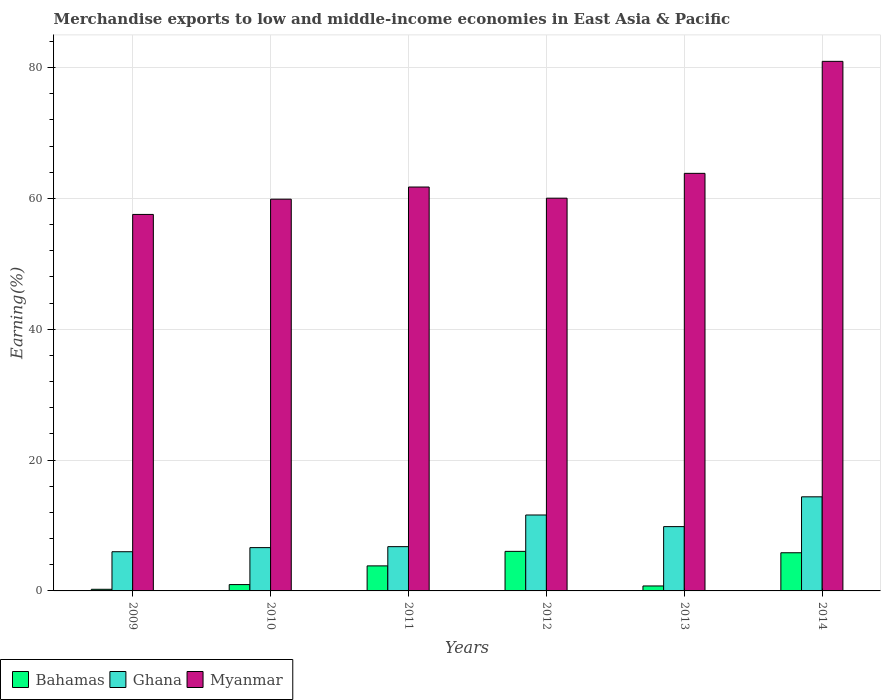How many different coloured bars are there?
Your response must be concise. 3. How many groups of bars are there?
Your answer should be compact. 6. Are the number of bars per tick equal to the number of legend labels?
Keep it short and to the point. Yes. How many bars are there on the 2nd tick from the left?
Provide a succinct answer. 3. What is the label of the 5th group of bars from the left?
Keep it short and to the point. 2013. What is the percentage of amount earned from merchandise exports in Bahamas in 2014?
Ensure brevity in your answer.  5.83. Across all years, what is the maximum percentage of amount earned from merchandise exports in Bahamas?
Provide a succinct answer. 6.05. Across all years, what is the minimum percentage of amount earned from merchandise exports in Ghana?
Make the answer very short. 5.99. What is the total percentage of amount earned from merchandise exports in Bahamas in the graph?
Make the answer very short. 17.68. What is the difference between the percentage of amount earned from merchandise exports in Bahamas in 2011 and that in 2014?
Offer a very short reply. -2.01. What is the difference between the percentage of amount earned from merchandise exports in Myanmar in 2009 and the percentage of amount earned from merchandise exports in Ghana in 2012?
Offer a terse response. 45.94. What is the average percentage of amount earned from merchandise exports in Bahamas per year?
Keep it short and to the point. 2.95. In the year 2012, what is the difference between the percentage of amount earned from merchandise exports in Myanmar and percentage of amount earned from merchandise exports in Ghana?
Your answer should be compact. 48.43. In how many years, is the percentage of amount earned from merchandise exports in Myanmar greater than 76 %?
Your response must be concise. 1. What is the ratio of the percentage of amount earned from merchandise exports in Bahamas in 2009 to that in 2014?
Your answer should be compact. 0.04. Is the percentage of amount earned from merchandise exports in Myanmar in 2011 less than that in 2014?
Your response must be concise. Yes. What is the difference between the highest and the second highest percentage of amount earned from merchandise exports in Myanmar?
Ensure brevity in your answer.  17.12. What is the difference between the highest and the lowest percentage of amount earned from merchandise exports in Bahamas?
Provide a short and direct response. 5.8. In how many years, is the percentage of amount earned from merchandise exports in Myanmar greater than the average percentage of amount earned from merchandise exports in Myanmar taken over all years?
Your answer should be compact. 1. Is the sum of the percentage of amount earned from merchandise exports in Ghana in 2009 and 2012 greater than the maximum percentage of amount earned from merchandise exports in Myanmar across all years?
Your answer should be very brief. No. What does the 1st bar from the left in 2010 represents?
Your answer should be very brief. Bahamas. What does the 3rd bar from the right in 2013 represents?
Your response must be concise. Bahamas. Is it the case that in every year, the sum of the percentage of amount earned from merchandise exports in Ghana and percentage of amount earned from merchandise exports in Bahamas is greater than the percentage of amount earned from merchandise exports in Myanmar?
Keep it short and to the point. No. How many bars are there?
Give a very brief answer. 18. How many years are there in the graph?
Your answer should be very brief. 6. Are the values on the major ticks of Y-axis written in scientific E-notation?
Make the answer very short. No. How many legend labels are there?
Offer a terse response. 3. How are the legend labels stacked?
Offer a very short reply. Horizontal. What is the title of the graph?
Ensure brevity in your answer.  Merchandise exports to low and middle-income economies in East Asia & Pacific. Does "Euro area" appear as one of the legend labels in the graph?
Your answer should be very brief. No. What is the label or title of the X-axis?
Offer a terse response. Years. What is the label or title of the Y-axis?
Your response must be concise. Earning(%). What is the Earning(%) of Bahamas in 2009?
Your answer should be compact. 0.25. What is the Earning(%) of Ghana in 2009?
Your response must be concise. 5.99. What is the Earning(%) of Myanmar in 2009?
Ensure brevity in your answer.  57.55. What is the Earning(%) of Bahamas in 2010?
Ensure brevity in your answer.  0.97. What is the Earning(%) in Ghana in 2010?
Provide a short and direct response. 6.62. What is the Earning(%) in Myanmar in 2010?
Your response must be concise. 59.88. What is the Earning(%) in Bahamas in 2011?
Your answer should be compact. 3.83. What is the Earning(%) in Ghana in 2011?
Offer a very short reply. 6.77. What is the Earning(%) in Myanmar in 2011?
Offer a very short reply. 61.73. What is the Earning(%) in Bahamas in 2012?
Keep it short and to the point. 6.05. What is the Earning(%) of Ghana in 2012?
Your response must be concise. 11.6. What is the Earning(%) of Myanmar in 2012?
Provide a short and direct response. 60.03. What is the Earning(%) in Bahamas in 2013?
Provide a short and direct response. 0.76. What is the Earning(%) in Ghana in 2013?
Offer a very short reply. 9.83. What is the Earning(%) of Myanmar in 2013?
Your answer should be very brief. 63.82. What is the Earning(%) in Bahamas in 2014?
Give a very brief answer. 5.83. What is the Earning(%) in Ghana in 2014?
Your answer should be compact. 14.38. What is the Earning(%) of Myanmar in 2014?
Provide a succinct answer. 80.94. Across all years, what is the maximum Earning(%) in Bahamas?
Ensure brevity in your answer.  6.05. Across all years, what is the maximum Earning(%) of Ghana?
Provide a succinct answer. 14.38. Across all years, what is the maximum Earning(%) of Myanmar?
Offer a very short reply. 80.94. Across all years, what is the minimum Earning(%) of Bahamas?
Your answer should be compact. 0.25. Across all years, what is the minimum Earning(%) of Ghana?
Your response must be concise. 5.99. Across all years, what is the minimum Earning(%) in Myanmar?
Keep it short and to the point. 57.55. What is the total Earning(%) in Bahamas in the graph?
Your response must be concise. 17.68. What is the total Earning(%) of Ghana in the graph?
Offer a very short reply. 55.2. What is the total Earning(%) in Myanmar in the graph?
Ensure brevity in your answer.  383.95. What is the difference between the Earning(%) of Bahamas in 2009 and that in 2010?
Your response must be concise. -0.72. What is the difference between the Earning(%) in Ghana in 2009 and that in 2010?
Provide a short and direct response. -0.63. What is the difference between the Earning(%) of Myanmar in 2009 and that in 2010?
Your response must be concise. -2.33. What is the difference between the Earning(%) of Bahamas in 2009 and that in 2011?
Give a very brief answer. -3.58. What is the difference between the Earning(%) in Ghana in 2009 and that in 2011?
Your answer should be very brief. -0.78. What is the difference between the Earning(%) in Myanmar in 2009 and that in 2011?
Offer a very short reply. -4.19. What is the difference between the Earning(%) in Bahamas in 2009 and that in 2012?
Your answer should be very brief. -5.8. What is the difference between the Earning(%) in Ghana in 2009 and that in 2012?
Offer a terse response. -5.61. What is the difference between the Earning(%) of Myanmar in 2009 and that in 2012?
Offer a terse response. -2.48. What is the difference between the Earning(%) in Bahamas in 2009 and that in 2013?
Keep it short and to the point. -0.51. What is the difference between the Earning(%) in Ghana in 2009 and that in 2013?
Give a very brief answer. -3.84. What is the difference between the Earning(%) in Myanmar in 2009 and that in 2013?
Provide a succinct answer. -6.28. What is the difference between the Earning(%) of Bahamas in 2009 and that in 2014?
Provide a short and direct response. -5.58. What is the difference between the Earning(%) of Ghana in 2009 and that in 2014?
Your answer should be very brief. -8.39. What is the difference between the Earning(%) in Myanmar in 2009 and that in 2014?
Your response must be concise. -23.4. What is the difference between the Earning(%) in Bahamas in 2010 and that in 2011?
Give a very brief answer. -2.86. What is the difference between the Earning(%) in Ghana in 2010 and that in 2011?
Provide a succinct answer. -0.15. What is the difference between the Earning(%) of Myanmar in 2010 and that in 2011?
Your answer should be very brief. -1.86. What is the difference between the Earning(%) of Bahamas in 2010 and that in 2012?
Provide a short and direct response. -5.08. What is the difference between the Earning(%) of Ghana in 2010 and that in 2012?
Make the answer very short. -4.98. What is the difference between the Earning(%) of Myanmar in 2010 and that in 2012?
Provide a succinct answer. -0.15. What is the difference between the Earning(%) of Bahamas in 2010 and that in 2013?
Your answer should be compact. 0.21. What is the difference between the Earning(%) of Ghana in 2010 and that in 2013?
Provide a succinct answer. -3.21. What is the difference between the Earning(%) in Myanmar in 2010 and that in 2013?
Provide a succinct answer. -3.95. What is the difference between the Earning(%) of Bahamas in 2010 and that in 2014?
Your response must be concise. -4.87. What is the difference between the Earning(%) of Ghana in 2010 and that in 2014?
Provide a short and direct response. -7.76. What is the difference between the Earning(%) of Myanmar in 2010 and that in 2014?
Your answer should be very brief. -21.07. What is the difference between the Earning(%) in Bahamas in 2011 and that in 2012?
Keep it short and to the point. -2.22. What is the difference between the Earning(%) in Ghana in 2011 and that in 2012?
Keep it short and to the point. -4.84. What is the difference between the Earning(%) in Myanmar in 2011 and that in 2012?
Your answer should be compact. 1.7. What is the difference between the Earning(%) in Bahamas in 2011 and that in 2013?
Your answer should be compact. 3.07. What is the difference between the Earning(%) in Ghana in 2011 and that in 2013?
Your response must be concise. -3.06. What is the difference between the Earning(%) of Myanmar in 2011 and that in 2013?
Ensure brevity in your answer.  -2.09. What is the difference between the Earning(%) of Bahamas in 2011 and that in 2014?
Provide a succinct answer. -2.01. What is the difference between the Earning(%) in Ghana in 2011 and that in 2014?
Keep it short and to the point. -7.61. What is the difference between the Earning(%) in Myanmar in 2011 and that in 2014?
Provide a short and direct response. -19.21. What is the difference between the Earning(%) of Bahamas in 2012 and that in 2013?
Your answer should be very brief. 5.29. What is the difference between the Earning(%) in Ghana in 2012 and that in 2013?
Your answer should be compact. 1.78. What is the difference between the Earning(%) of Myanmar in 2012 and that in 2013?
Your answer should be compact. -3.79. What is the difference between the Earning(%) in Bahamas in 2012 and that in 2014?
Your response must be concise. 0.21. What is the difference between the Earning(%) in Ghana in 2012 and that in 2014?
Ensure brevity in your answer.  -2.78. What is the difference between the Earning(%) of Myanmar in 2012 and that in 2014?
Offer a terse response. -20.91. What is the difference between the Earning(%) of Bahamas in 2013 and that in 2014?
Provide a succinct answer. -5.08. What is the difference between the Earning(%) of Ghana in 2013 and that in 2014?
Offer a terse response. -4.55. What is the difference between the Earning(%) in Myanmar in 2013 and that in 2014?
Make the answer very short. -17.12. What is the difference between the Earning(%) in Bahamas in 2009 and the Earning(%) in Ghana in 2010?
Your answer should be very brief. -6.37. What is the difference between the Earning(%) of Bahamas in 2009 and the Earning(%) of Myanmar in 2010?
Provide a short and direct response. -59.63. What is the difference between the Earning(%) in Ghana in 2009 and the Earning(%) in Myanmar in 2010?
Give a very brief answer. -53.89. What is the difference between the Earning(%) in Bahamas in 2009 and the Earning(%) in Ghana in 2011?
Ensure brevity in your answer.  -6.52. What is the difference between the Earning(%) in Bahamas in 2009 and the Earning(%) in Myanmar in 2011?
Give a very brief answer. -61.49. What is the difference between the Earning(%) of Ghana in 2009 and the Earning(%) of Myanmar in 2011?
Ensure brevity in your answer.  -55.74. What is the difference between the Earning(%) in Bahamas in 2009 and the Earning(%) in Ghana in 2012?
Give a very brief answer. -11.36. What is the difference between the Earning(%) in Bahamas in 2009 and the Earning(%) in Myanmar in 2012?
Provide a short and direct response. -59.78. What is the difference between the Earning(%) of Ghana in 2009 and the Earning(%) of Myanmar in 2012?
Keep it short and to the point. -54.04. What is the difference between the Earning(%) of Bahamas in 2009 and the Earning(%) of Ghana in 2013?
Your answer should be compact. -9.58. What is the difference between the Earning(%) of Bahamas in 2009 and the Earning(%) of Myanmar in 2013?
Provide a succinct answer. -63.57. What is the difference between the Earning(%) in Ghana in 2009 and the Earning(%) in Myanmar in 2013?
Offer a very short reply. -57.83. What is the difference between the Earning(%) of Bahamas in 2009 and the Earning(%) of Ghana in 2014?
Provide a succinct answer. -14.13. What is the difference between the Earning(%) in Bahamas in 2009 and the Earning(%) in Myanmar in 2014?
Provide a short and direct response. -80.69. What is the difference between the Earning(%) in Ghana in 2009 and the Earning(%) in Myanmar in 2014?
Give a very brief answer. -74.95. What is the difference between the Earning(%) in Bahamas in 2010 and the Earning(%) in Ghana in 2011?
Offer a very short reply. -5.8. What is the difference between the Earning(%) in Bahamas in 2010 and the Earning(%) in Myanmar in 2011?
Provide a short and direct response. -60.77. What is the difference between the Earning(%) of Ghana in 2010 and the Earning(%) of Myanmar in 2011?
Give a very brief answer. -55.11. What is the difference between the Earning(%) in Bahamas in 2010 and the Earning(%) in Ghana in 2012?
Keep it short and to the point. -10.64. What is the difference between the Earning(%) in Bahamas in 2010 and the Earning(%) in Myanmar in 2012?
Offer a very short reply. -59.06. What is the difference between the Earning(%) of Ghana in 2010 and the Earning(%) of Myanmar in 2012?
Keep it short and to the point. -53.41. What is the difference between the Earning(%) in Bahamas in 2010 and the Earning(%) in Ghana in 2013?
Offer a very short reply. -8.86. What is the difference between the Earning(%) of Bahamas in 2010 and the Earning(%) of Myanmar in 2013?
Your answer should be compact. -62.86. What is the difference between the Earning(%) of Ghana in 2010 and the Earning(%) of Myanmar in 2013?
Ensure brevity in your answer.  -57.2. What is the difference between the Earning(%) in Bahamas in 2010 and the Earning(%) in Ghana in 2014?
Your response must be concise. -13.41. What is the difference between the Earning(%) in Bahamas in 2010 and the Earning(%) in Myanmar in 2014?
Provide a succinct answer. -79.97. What is the difference between the Earning(%) in Ghana in 2010 and the Earning(%) in Myanmar in 2014?
Offer a terse response. -74.32. What is the difference between the Earning(%) in Bahamas in 2011 and the Earning(%) in Ghana in 2012?
Your answer should be very brief. -7.78. What is the difference between the Earning(%) in Bahamas in 2011 and the Earning(%) in Myanmar in 2012?
Give a very brief answer. -56.2. What is the difference between the Earning(%) of Ghana in 2011 and the Earning(%) of Myanmar in 2012?
Provide a succinct answer. -53.26. What is the difference between the Earning(%) in Bahamas in 2011 and the Earning(%) in Ghana in 2013?
Your answer should be compact. -6. What is the difference between the Earning(%) in Bahamas in 2011 and the Earning(%) in Myanmar in 2013?
Offer a very short reply. -60. What is the difference between the Earning(%) of Ghana in 2011 and the Earning(%) of Myanmar in 2013?
Your response must be concise. -57.06. What is the difference between the Earning(%) in Bahamas in 2011 and the Earning(%) in Ghana in 2014?
Offer a terse response. -10.56. What is the difference between the Earning(%) in Bahamas in 2011 and the Earning(%) in Myanmar in 2014?
Ensure brevity in your answer.  -77.12. What is the difference between the Earning(%) in Ghana in 2011 and the Earning(%) in Myanmar in 2014?
Make the answer very short. -74.17. What is the difference between the Earning(%) in Bahamas in 2012 and the Earning(%) in Ghana in 2013?
Your response must be concise. -3.78. What is the difference between the Earning(%) in Bahamas in 2012 and the Earning(%) in Myanmar in 2013?
Make the answer very short. -57.78. What is the difference between the Earning(%) in Ghana in 2012 and the Earning(%) in Myanmar in 2013?
Your answer should be very brief. -52.22. What is the difference between the Earning(%) in Bahamas in 2012 and the Earning(%) in Ghana in 2014?
Keep it short and to the point. -8.34. What is the difference between the Earning(%) of Bahamas in 2012 and the Earning(%) of Myanmar in 2014?
Ensure brevity in your answer.  -74.9. What is the difference between the Earning(%) of Ghana in 2012 and the Earning(%) of Myanmar in 2014?
Your answer should be very brief. -69.34. What is the difference between the Earning(%) in Bahamas in 2013 and the Earning(%) in Ghana in 2014?
Your response must be concise. -13.63. What is the difference between the Earning(%) in Bahamas in 2013 and the Earning(%) in Myanmar in 2014?
Keep it short and to the point. -80.19. What is the difference between the Earning(%) in Ghana in 2013 and the Earning(%) in Myanmar in 2014?
Keep it short and to the point. -71.11. What is the average Earning(%) in Bahamas per year?
Keep it short and to the point. 2.95. What is the average Earning(%) of Ghana per year?
Ensure brevity in your answer.  9.2. What is the average Earning(%) of Myanmar per year?
Offer a very short reply. 63.99. In the year 2009, what is the difference between the Earning(%) of Bahamas and Earning(%) of Ghana?
Provide a short and direct response. -5.74. In the year 2009, what is the difference between the Earning(%) of Bahamas and Earning(%) of Myanmar?
Offer a very short reply. -57.3. In the year 2009, what is the difference between the Earning(%) of Ghana and Earning(%) of Myanmar?
Your answer should be compact. -51.55. In the year 2010, what is the difference between the Earning(%) of Bahamas and Earning(%) of Ghana?
Offer a very short reply. -5.65. In the year 2010, what is the difference between the Earning(%) of Bahamas and Earning(%) of Myanmar?
Provide a short and direct response. -58.91. In the year 2010, what is the difference between the Earning(%) in Ghana and Earning(%) in Myanmar?
Your answer should be compact. -53.26. In the year 2011, what is the difference between the Earning(%) in Bahamas and Earning(%) in Ghana?
Provide a succinct answer. -2.94. In the year 2011, what is the difference between the Earning(%) in Bahamas and Earning(%) in Myanmar?
Your response must be concise. -57.91. In the year 2011, what is the difference between the Earning(%) in Ghana and Earning(%) in Myanmar?
Provide a succinct answer. -54.97. In the year 2012, what is the difference between the Earning(%) in Bahamas and Earning(%) in Ghana?
Your response must be concise. -5.56. In the year 2012, what is the difference between the Earning(%) of Bahamas and Earning(%) of Myanmar?
Your response must be concise. -53.98. In the year 2012, what is the difference between the Earning(%) in Ghana and Earning(%) in Myanmar?
Ensure brevity in your answer.  -48.43. In the year 2013, what is the difference between the Earning(%) of Bahamas and Earning(%) of Ghana?
Provide a succinct answer. -9.07. In the year 2013, what is the difference between the Earning(%) in Bahamas and Earning(%) in Myanmar?
Your answer should be compact. -63.07. In the year 2013, what is the difference between the Earning(%) in Ghana and Earning(%) in Myanmar?
Provide a short and direct response. -53.99. In the year 2014, what is the difference between the Earning(%) of Bahamas and Earning(%) of Ghana?
Make the answer very short. -8.55. In the year 2014, what is the difference between the Earning(%) of Bahamas and Earning(%) of Myanmar?
Your answer should be very brief. -75.11. In the year 2014, what is the difference between the Earning(%) of Ghana and Earning(%) of Myanmar?
Keep it short and to the point. -66.56. What is the ratio of the Earning(%) of Bahamas in 2009 to that in 2010?
Make the answer very short. 0.26. What is the ratio of the Earning(%) in Ghana in 2009 to that in 2010?
Your response must be concise. 0.91. What is the ratio of the Earning(%) in Myanmar in 2009 to that in 2010?
Your answer should be compact. 0.96. What is the ratio of the Earning(%) in Bahamas in 2009 to that in 2011?
Offer a very short reply. 0.07. What is the ratio of the Earning(%) in Ghana in 2009 to that in 2011?
Provide a succinct answer. 0.89. What is the ratio of the Earning(%) of Myanmar in 2009 to that in 2011?
Your answer should be very brief. 0.93. What is the ratio of the Earning(%) of Bahamas in 2009 to that in 2012?
Your answer should be compact. 0.04. What is the ratio of the Earning(%) of Ghana in 2009 to that in 2012?
Your answer should be compact. 0.52. What is the ratio of the Earning(%) of Myanmar in 2009 to that in 2012?
Offer a terse response. 0.96. What is the ratio of the Earning(%) in Bahamas in 2009 to that in 2013?
Provide a short and direct response. 0.33. What is the ratio of the Earning(%) of Ghana in 2009 to that in 2013?
Keep it short and to the point. 0.61. What is the ratio of the Earning(%) in Myanmar in 2009 to that in 2013?
Your answer should be compact. 0.9. What is the ratio of the Earning(%) in Bahamas in 2009 to that in 2014?
Your answer should be compact. 0.04. What is the ratio of the Earning(%) in Ghana in 2009 to that in 2014?
Your response must be concise. 0.42. What is the ratio of the Earning(%) of Myanmar in 2009 to that in 2014?
Offer a very short reply. 0.71. What is the ratio of the Earning(%) in Bahamas in 2010 to that in 2011?
Keep it short and to the point. 0.25. What is the ratio of the Earning(%) in Ghana in 2010 to that in 2011?
Give a very brief answer. 0.98. What is the ratio of the Earning(%) in Myanmar in 2010 to that in 2011?
Provide a succinct answer. 0.97. What is the ratio of the Earning(%) of Bahamas in 2010 to that in 2012?
Ensure brevity in your answer.  0.16. What is the ratio of the Earning(%) in Ghana in 2010 to that in 2012?
Provide a succinct answer. 0.57. What is the ratio of the Earning(%) of Myanmar in 2010 to that in 2012?
Your response must be concise. 1. What is the ratio of the Earning(%) in Bahamas in 2010 to that in 2013?
Offer a terse response. 1.28. What is the ratio of the Earning(%) in Ghana in 2010 to that in 2013?
Offer a very short reply. 0.67. What is the ratio of the Earning(%) in Myanmar in 2010 to that in 2013?
Keep it short and to the point. 0.94. What is the ratio of the Earning(%) in Bahamas in 2010 to that in 2014?
Your answer should be compact. 0.17. What is the ratio of the Earning(%) in Ghana in 2010 to that in 2014?
Offer a very short reply. 0.46. What is the ratio of the Earning(%) of Myanmar in 2010 to that in 2014?
Offer a very short reply. 0.74. What is the ratio of the Earning(%) of Bahamas in 2011 to that in 2012?
Offer a terse response. 0.63. What is the ratio of the Earning(%) in Ghana in 2011 to that in 2012?
Offer a very short reply. 0.58. What is the ratio of the Earning(%) in Myanmar in 2011 to that in 2012?
Provide a succinct answer. 1.03. What is the ratio of the Earning(%) in Bahamas in 2011 to that in 2013?
Provide a short and direct response. 5.05. What is the ratio of the Earning(%) of Ghana in 2011 to that in 2013?
Give a very brief answer. 0.69. What is the ratio of the Earning(%) of Myanmar in 2011 to that in 2013?
Provide a succinct answer. 0.97. What is the ratio of the Earning(%) of Bahamas in 2011 to that in 2014?
Offer a terse response. 0.66. What is the ratio of the Earning(%) of Ghana in 2011 to that in 2014?
Provide a short and direct response. 0.47. What is the ratio of the Earning(%) in Myanmar in 2011 to that in 2014?
Offer a very short reply. 0.76. What is the ratio of the Earning(%) of Bahamas in 2012 to that in 2013?
Offer a terse response. 7.98. What is the ratio of the Earning(%) of Ghana in 2012 to that in 2013?
Your response must be concise. 1.18. What is the ratio of the Earning(%) of Myanmar in 2012 to that in 2013?
Ensure brevity in your answer.  0.94. What is the ratio of the Earning(%) in Bahamas in 2012 to that in 2014?
Make the answer very short. 1.04. What is the ratio of the Earning(%) of Ghana in 2012 to that in 2014?
Your answer should be compact. 0.81. What is the ratio of the Earning(%) of Myanmar in 2012 to that in 2014?
Provide a short and direct response. 0.74. What is the ratio of the Earning(%) in Bahamas in 2013 to that in 2014?
Make the answer very short. 0.13. What is the ratio of the Earning(%) in Ghana in 2013 to that in 2014?
Your response must be concise. 0.68. What is the ratio of the Earning(%) of Myanmar in 2013 to that in 2014?
Your answer should be very brief. 0.79. What is the difference between the highest and the second highest Earning(%) of Bahamas?
Ensure brevity in your answer.  0.21. What is the difference between the highest and the second highest Earning(%) of Ghana?
Offer a terse response. 2.78. What is the difference between the highest and the second highest Earning(%) in Myanmar?
Offer a very short reply. 17.12. What is the difference between the highest and the lowest Earning(%) of Bahamas?
Offer a very short reply. 5.8. What is the difference between the highest and the lowest Earning(%) in Ghana?
Offer a very short reply. 8.39. What is the difference between the highest and the lowest Earning(%) in Myanmar?
Keep it short and to the point. 23.4. 